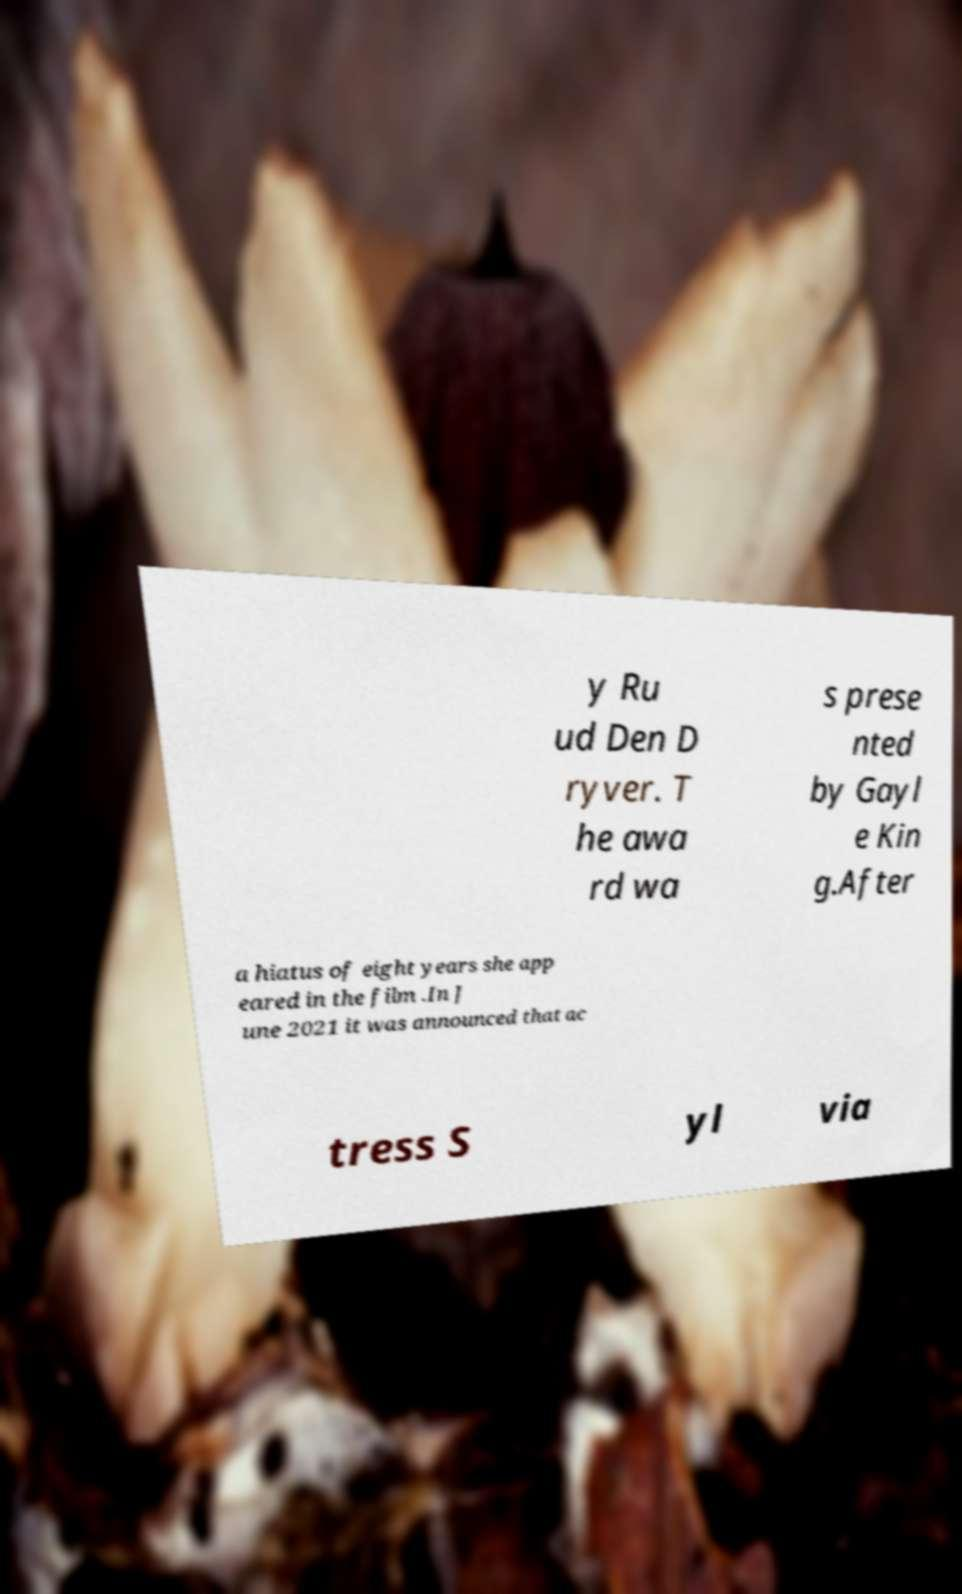Please identify and transcribe the text found in this image. y Ru ud Den D ryver. T he awa rd wa s prese nted by Gayl e Kin g.After a hiatus of eight years she app eared in the film .In J une 2021 it was announced that ac tress S yl via 